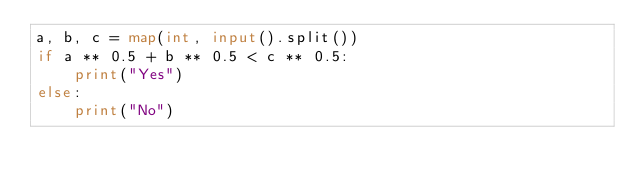Convert code to text. <code><loc_0><loc_0><loc_500><loc_500><_Python_>a, b, c = map(int, input().split())
if a ** 0.5 + b ** 0.5 < c ** 0.5:
    print("Yes")
else:
    print("No")</code> 